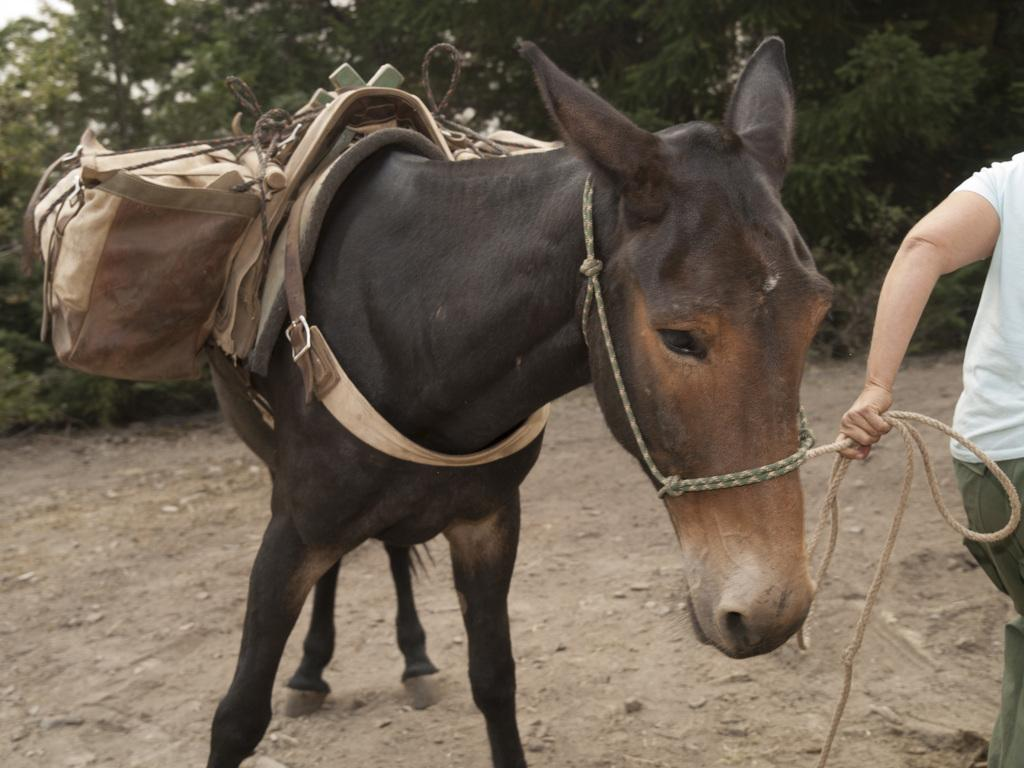What animal is in the foreground of the image? There is a donkey in the foreground of the image. What is attached to the donkey's back? The donkey has bags tied on its back. Who is holding a rope in the image? There is a person holding a rope on the right side of the image. What can be seen in the background of the image? There are trees in the background of the image. What type of glue is being used to attach the bags to the donkey's back? There is no glue present in the image, and the bags are tied to the donkey's back. Can you see a cow in the image? No, there is no cow present in the image; it features a donkey with bags tied on its back. 